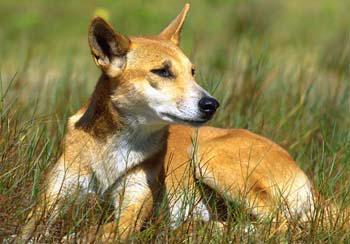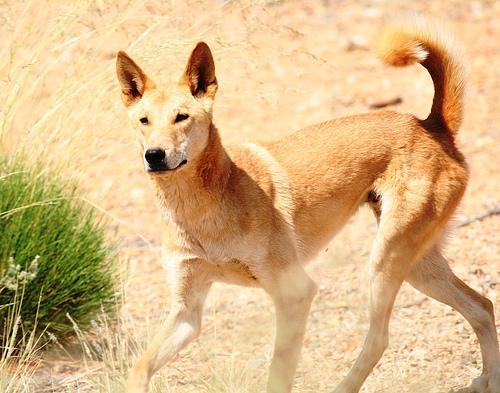The first image is the image on the left, the second image is the image on the right. Considering the images on both sides, is "The dingo on the right is laying on the grass." valid? Answer yes or no. No. 